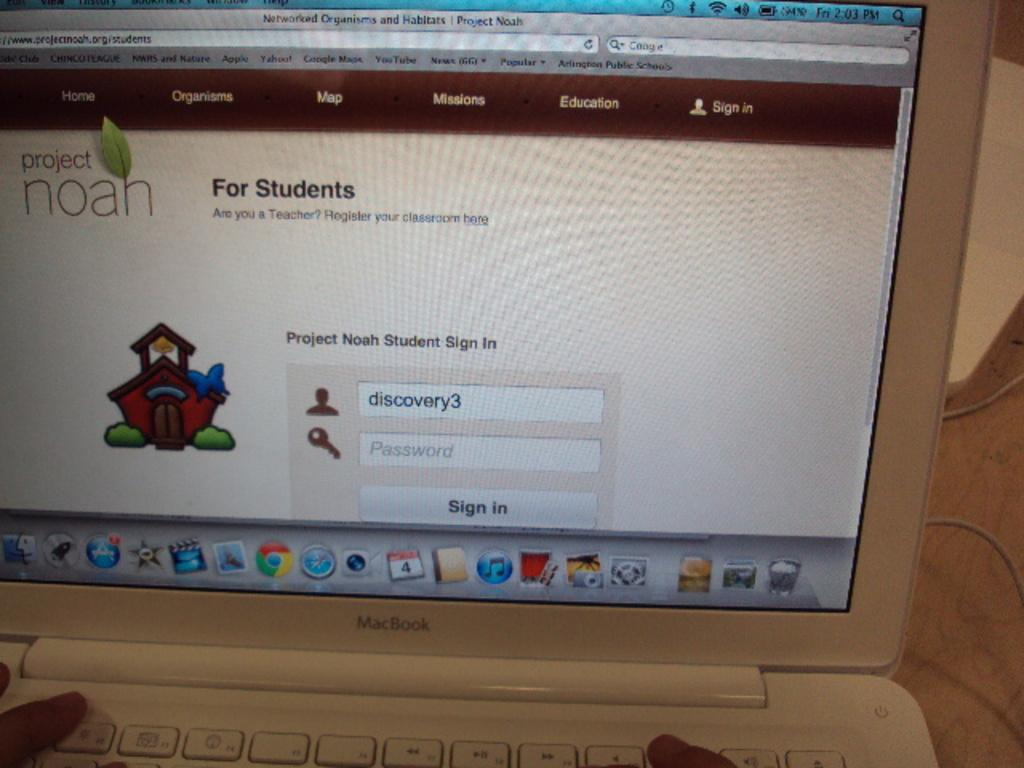<image>
Render a clear and concise summary of the photo. A computer screen shows the Project Noah site, which is for students. 